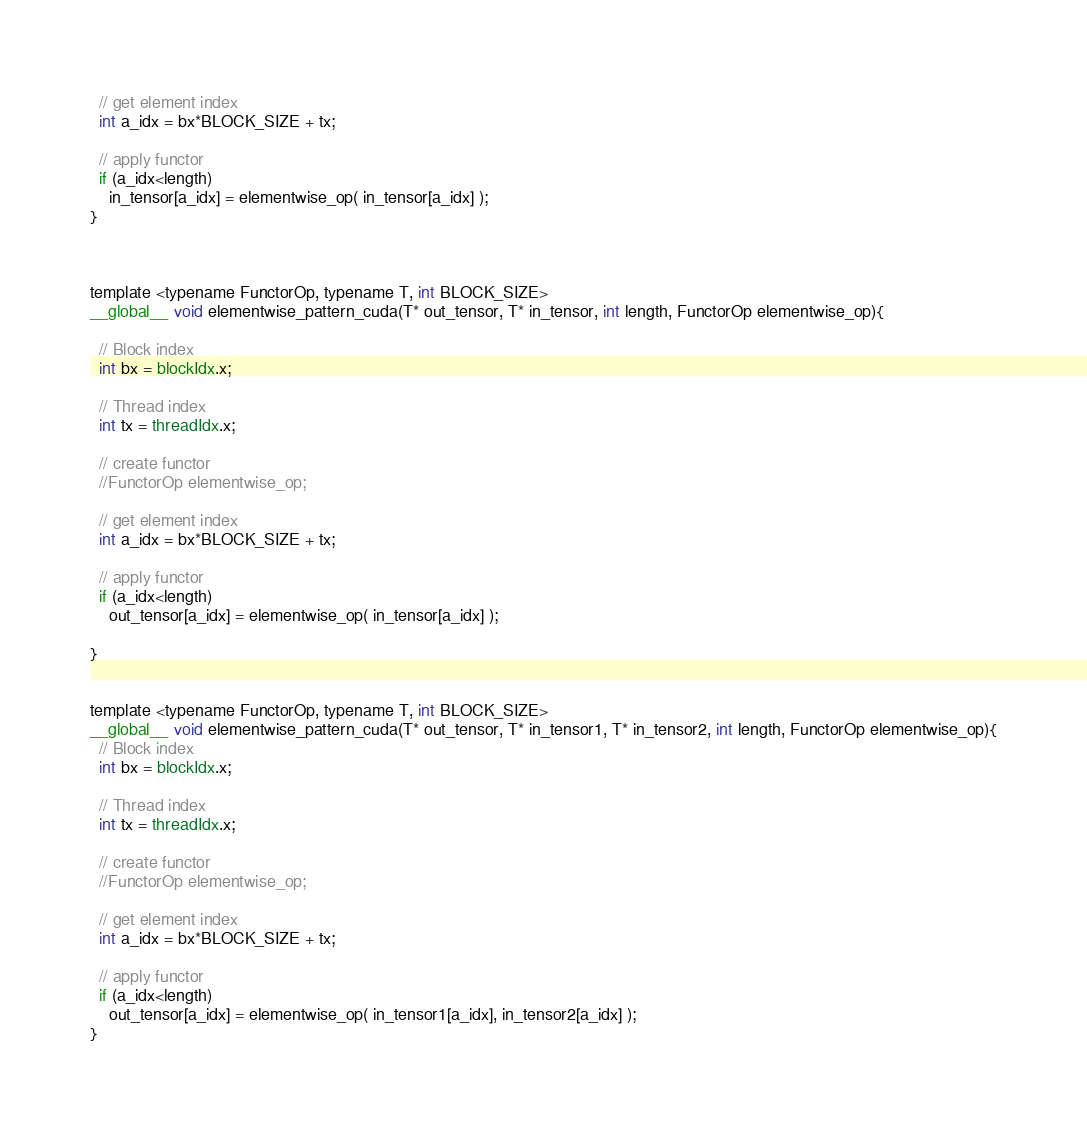<code> <loc_0><loc_0><loc_500><loc_500><_Cuda_>
  // get element index
  int a_idx = bx*BLOCK_SIZE + tx;

  // apply functor
  if (a_idx<length)
    in_tensor[a_idx] = elementwise_op( in_tensor[a_idx] );
}



template <typename FunctorOp, typename T, int BLOCK_SIZE>
__global__ void elementwise_pattern_cuda(T* out_tensor, T* in_tensor, int length, FunctorOp elementwise_op){

  // Block index
  int bx = blockIdx.x;

  // Thread index
  int tx = threadIdx.x;

  // create functor
  //FunctorOp elementwise_op;

  // get element index
  int a_idx = bx*BLOCK_SIZE + tx;

  // apply functor
  if (a_idx<length)
    out_tensor[a_idx] = elementwise_op( in_tensor[a_idx] );

}


template <typename FunctorOp, typename T, int BLOCK_SIZE>
__global__ void elementwise_pattern_cuda(T* out_tensor, T* in_tensor1, T* in_tensor2, int length, FunctorOp elementwise_op){
  // Block index
  int bx = blockIdx.x;

  // Thread index
  int tx = threadIdx.x;

  // create functor
  //FunctorOp elementwise_op;

  // get element index
  int a_idx = bx*BLOCK_SIZE + tx;

  // apply functor
  if (a_idx<length)
    out_tensor[a_idx] = elementwise_op( in_tensor1[a_idx], in_tensor2[a_idx] );
}
</code> 